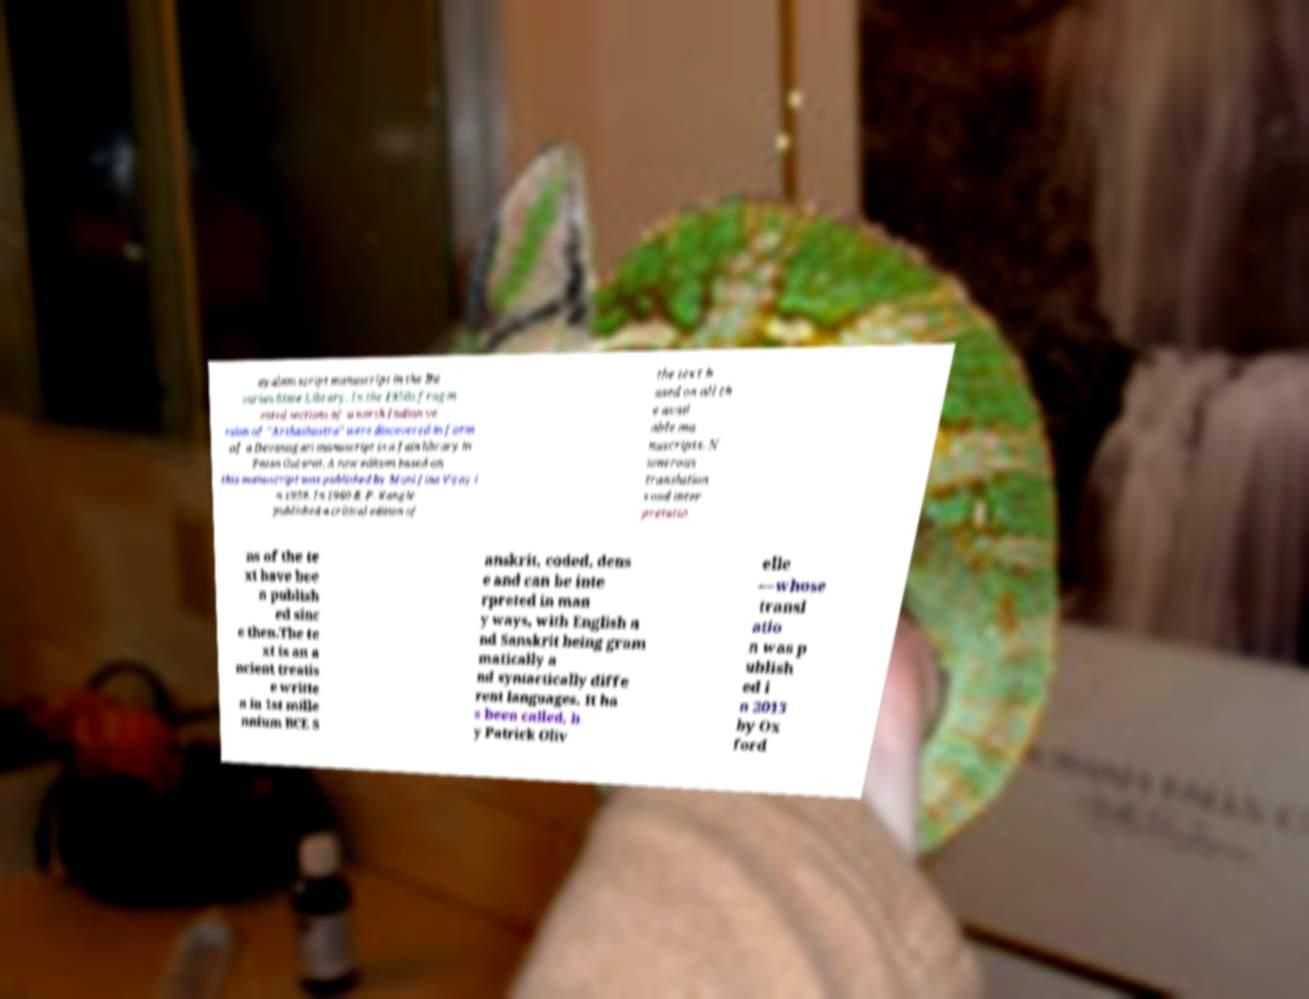Can you read and provide the text displayed in the image?This photo seems to have some interesting text. Can you extract and type it out for me? ayalam script manuscript in the Ba varian State Library. In the 1950s fragm ented sections of a north Indian ve rsion of "Arthashastra" were discovered in form of a Devanagari manuscript in a Jain library in Patan Gujarat. A new edition based on this manuscript was published by Muni Jina Vijay i n 1959. In 1960 R. P. Kangle published a critical edition of the text b ased on all th e avail able ma nuscripts. N umerous translation s and inter pretatio ns of the te xt have bee n publish ed sinc e then.The te xt is an a ncient treatis e writte n in 1st mille nnium BCE S anskrit, coded, dens e and can be inte rpreted in man y ways, with English a nd Sanskrit being gram matically a nd syntactically diffe rent languages. It ha s been called, b y Patrick Oliv elle —whose transl atio n was p ublish ed i n 2013 by Ox ford 